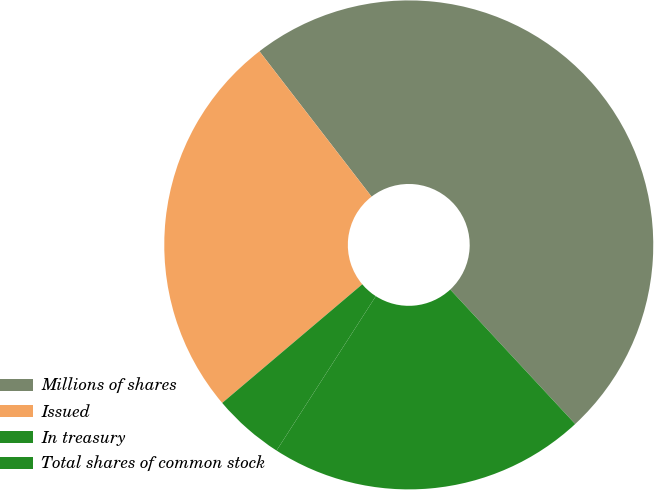Convert chart to OTSL. <chart><loc_0><loc_0><loc_500><loc_500><pie_chart><fcel>Millions of shares<fcel>Issued<fcel>In treasury<fcel>Total shares of common stock<nl><fcel>48.54%<fcel>25.73%<fcel>4.72%<fcel>21.01%<nl></chart> 